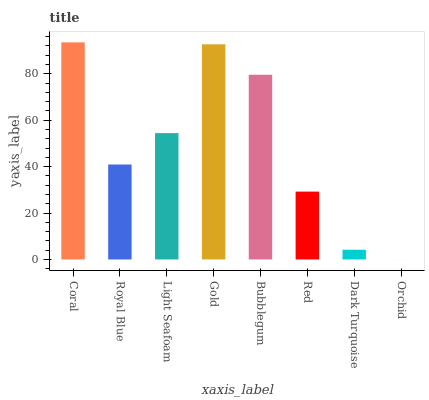Is Orchid the minimum?
Answer yes or no. Yes. Is Coral the maximum?
Answer yes or no. Yes. Is Royal Blue the minimum?
Answer yes or no. No. Is Royal Blue the maximum?
Answer yes or no. No. Is Coral greater than Royal Blue?
Answer yes or no. Yes. Is Royal Blue less than Coral?
Answer yes or no. Yes. Is Royal Blue greater than Coral?
Answer yes or no. No. Is Coral less than Royal Blue?
Answer yes or no. No. Is Light Seafoam the high median?
Answer yes or no. Yes. Is Royal Blue the low median?
Answer yes or no. Yes. Is Gold the high median?
Answer yes or no. No. Is Red the low median?
Answer yes or no. No. 